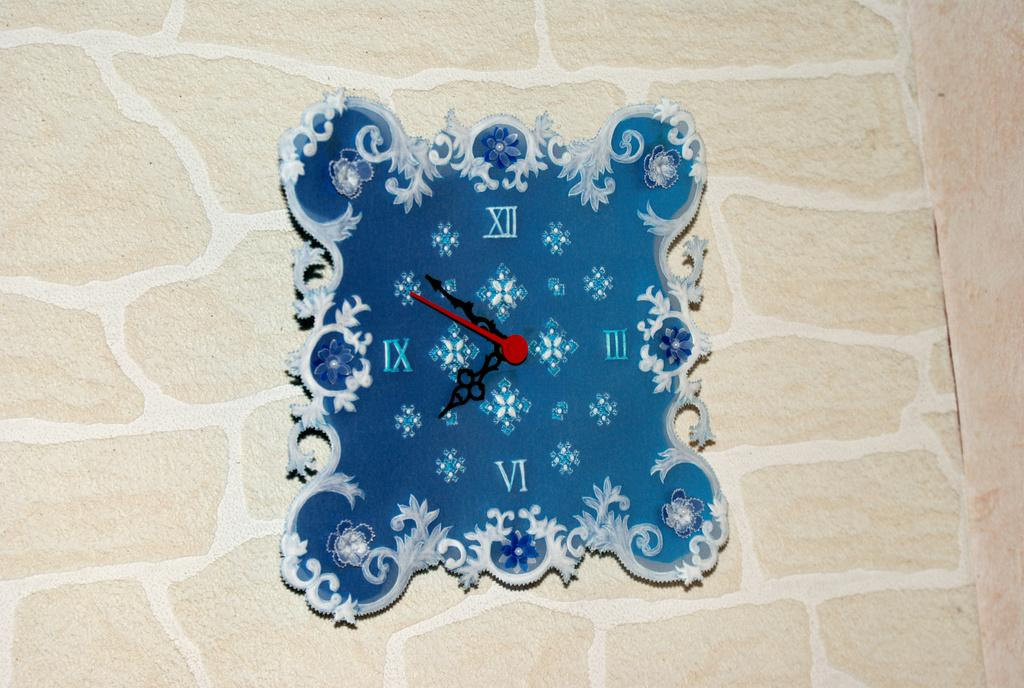<image>
Write a terse but informative summary of the picture. Square and blue clcokthat has the roman number 3 on the right. 